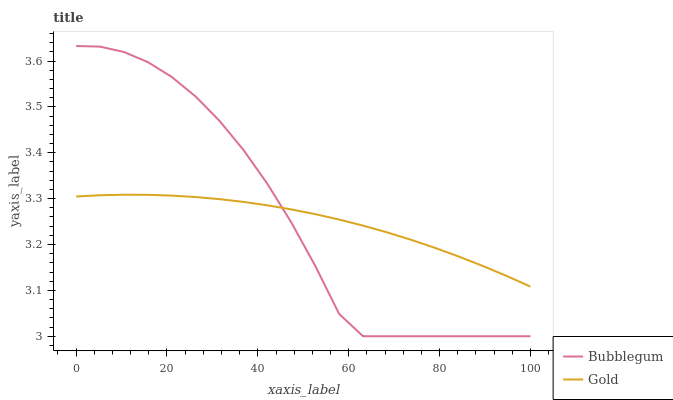Does Bubblegum have the minimum area under the curve?
Answer yes or no. No. Is Bubblegum the smoothest?
Answer yes or no. No. 